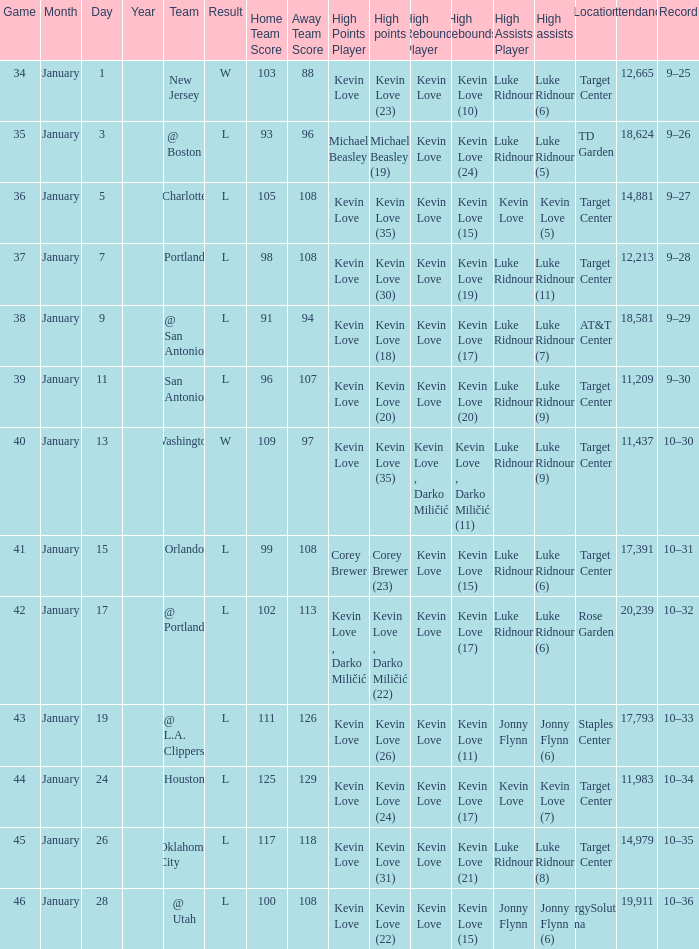What is the date for the game 35? January 3. 